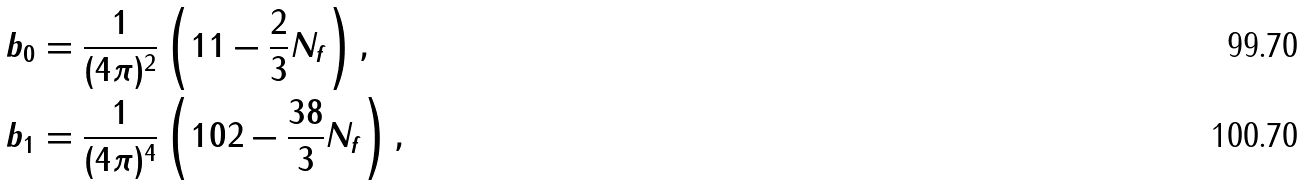Convert formula to latex. <formula><loc_0><loc_0><loc_500><loc_500>b _ { 0 } & = \frac { 1 } { ( 4 \pi ) ^ { 2 } } \left ( 1 1 - \frac { 2 } { 3 } N _ { f } \right ) , \\ b _ { 1 } & = \frac { 1 } { ( 4 \pi ) ^ { 4 } } \left ( 1 0 2 - \frac { 3 8 } { 3 } N _ { f } \right ) ,</formula> 